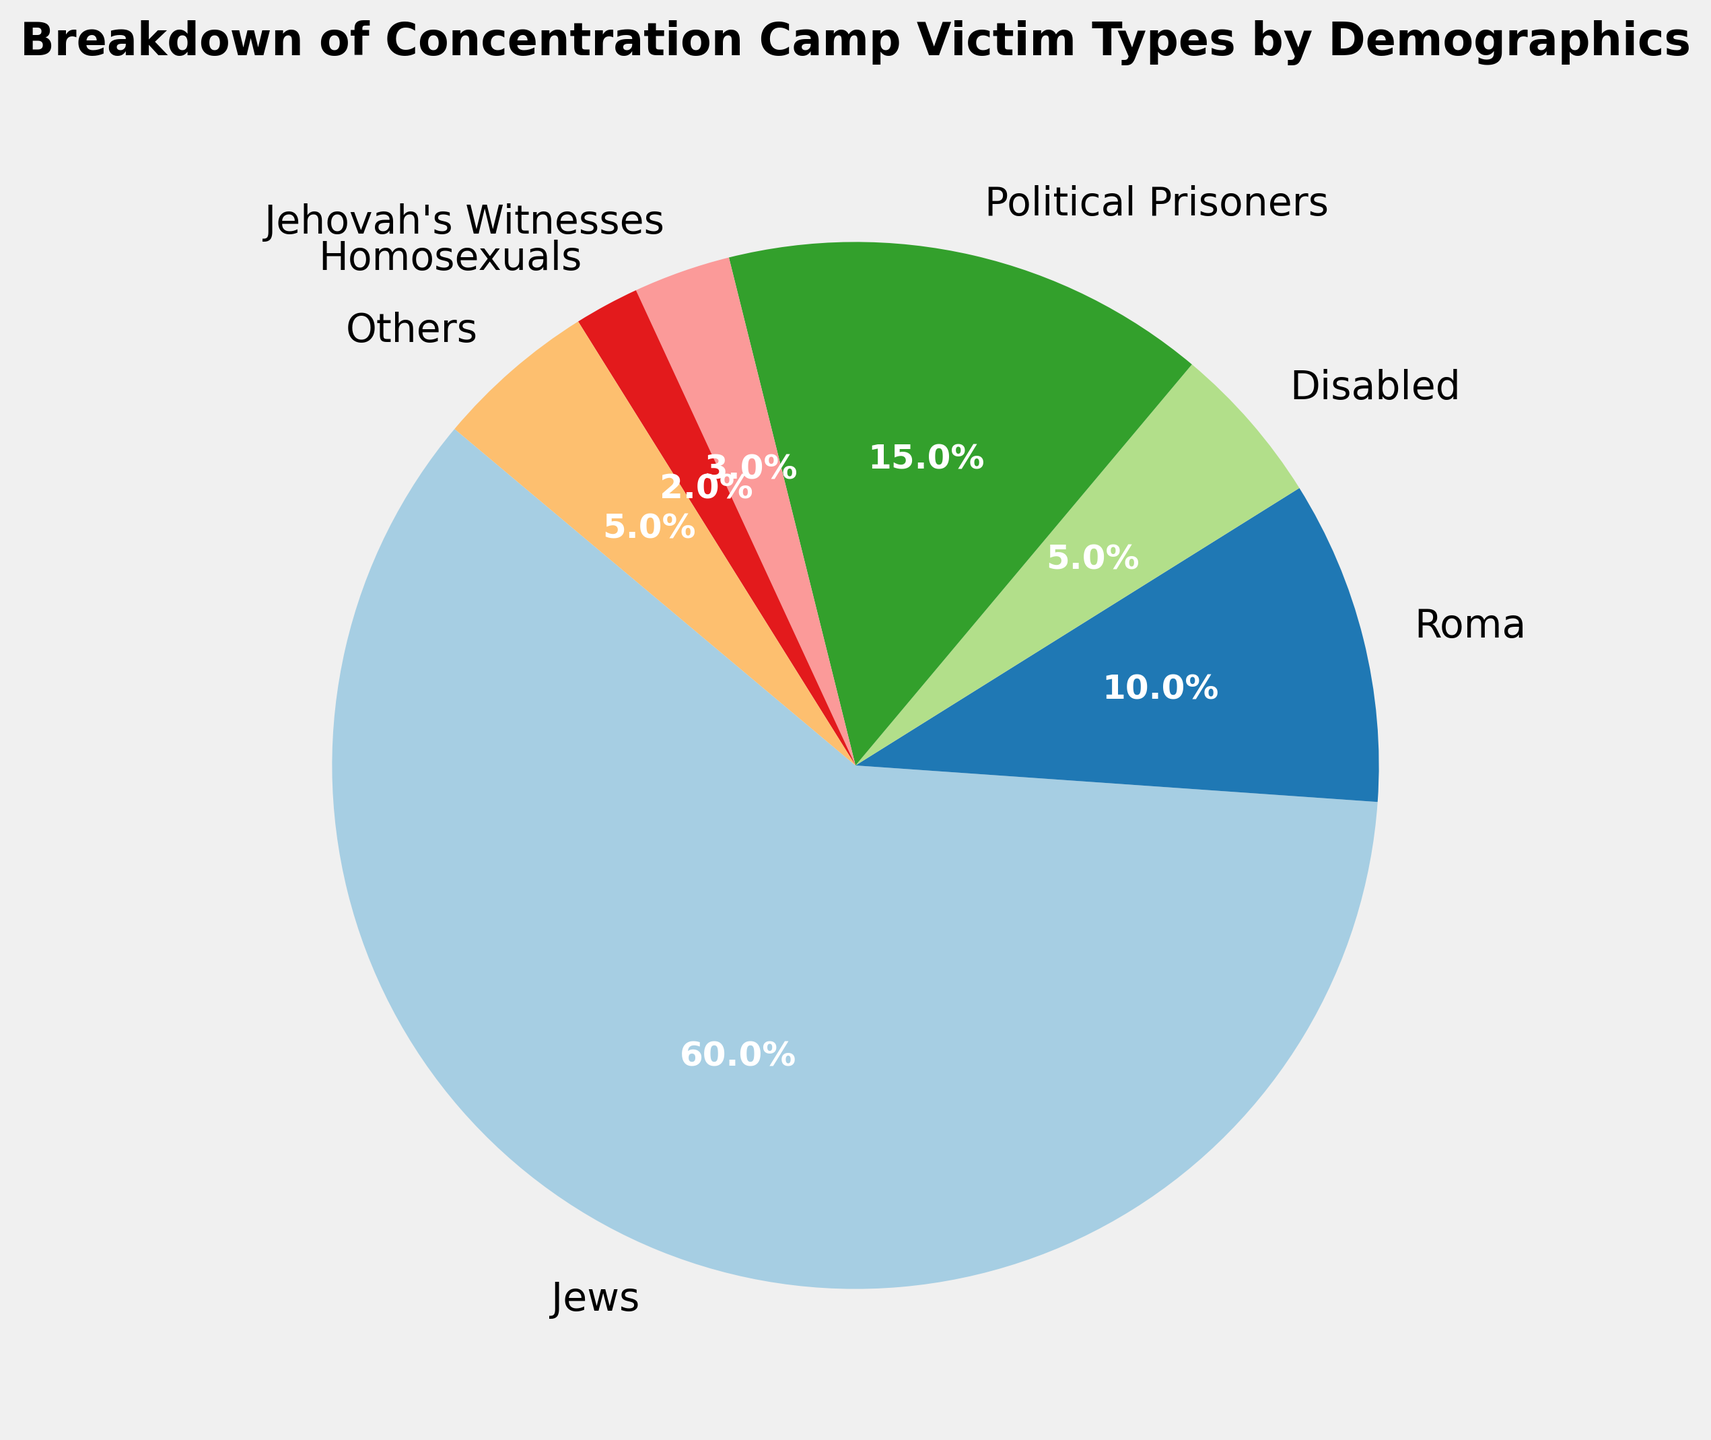what percentage of Holocaust victims were Jews and Roma together? Sum the percentages for Jews and Roma: Jews are 60% and Roma are 10%. 60% + 10% = 70%
Answer: 70% which group comprises a smaller percentage of victims: Disabled or Jehovah's Witnesses? Compare the percentages of Disabled (5%) and Jehovah's Witnesses (3%). 5% > 3%, so Jehovah's Witnesses comprise a smaller percentage
Answer: Jehovah's Witnesses what is the percentage difference between Political Prisoners and Homosexuals? Subtract the percentage of Homosexuals (2%) from that of Political Prisoners (15%). 15% - 2% = 13%
Answer: 13% how do Political Prisoners and Jehovah's Witnesses together compare to Jews in terms of percentage? Sum the percentages of Political Prisoners (15%) and Jehovah's Witnesses (3%) and compare it to Jews (60%). 15% + 3% = 18%, which is less than 60%
Answer: Less what proportion of the total victims fall into the "Others" category? The "Others" category comprises 5% of the victims as shown in the pie chart
Answer: 5% which demographic group has the second-largest representation among Holocaust victims? The largest group is Jews at 60%. The second-largest group is Political Prisoners at 15%
Answer: Political Prisoners what is the total percentage of victims that were either Disabled or from the "Others" category? Sum the percentages for Disabled (5%) and Others (5%). 5% + 5% = 10%
Answer: 10% how many demographic groups have a representation of less than 10% each? Count the categories with percentages less than 10%: Disabled (5%), Jehovah's Witnesses (3%), Homosexuals (2%), and Others (5%). There are four such groups
Answer: 4 compare the total percentage of non-Jewish victim groups to Jewish victims Sum the percentages of all non-Jewish groups: 10% (Roma) + 5% (Disabled) + 15% (Political Prisoners) + 3% (Jehovah's Witnesses) + 2% (Homosexuals) + 5% (Others) = 40%. Compare this to Jews (60%). 40% is less than 60%
Answer: Less which group has a percentage representation similar to the combined percentage of Jehovah's Witnesses and Homosexuals? Sum the percentages of Jehovah's Witnesses (3%) and Homosexuals (2%). 3% + 2% = 5%, which is equal to the percentage for Disabled and Others
Answer: Disabled/Others 